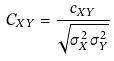Convert formula to latex. <formula><loc_0><loc_0><loc_500><loc_500>C _ { X Y } = \frac { c _ { X Y } } { \sqrt { \sigma ^ { 2 } _ { X } \sigma ^ { 2 } _ { Y } } }</formula> 